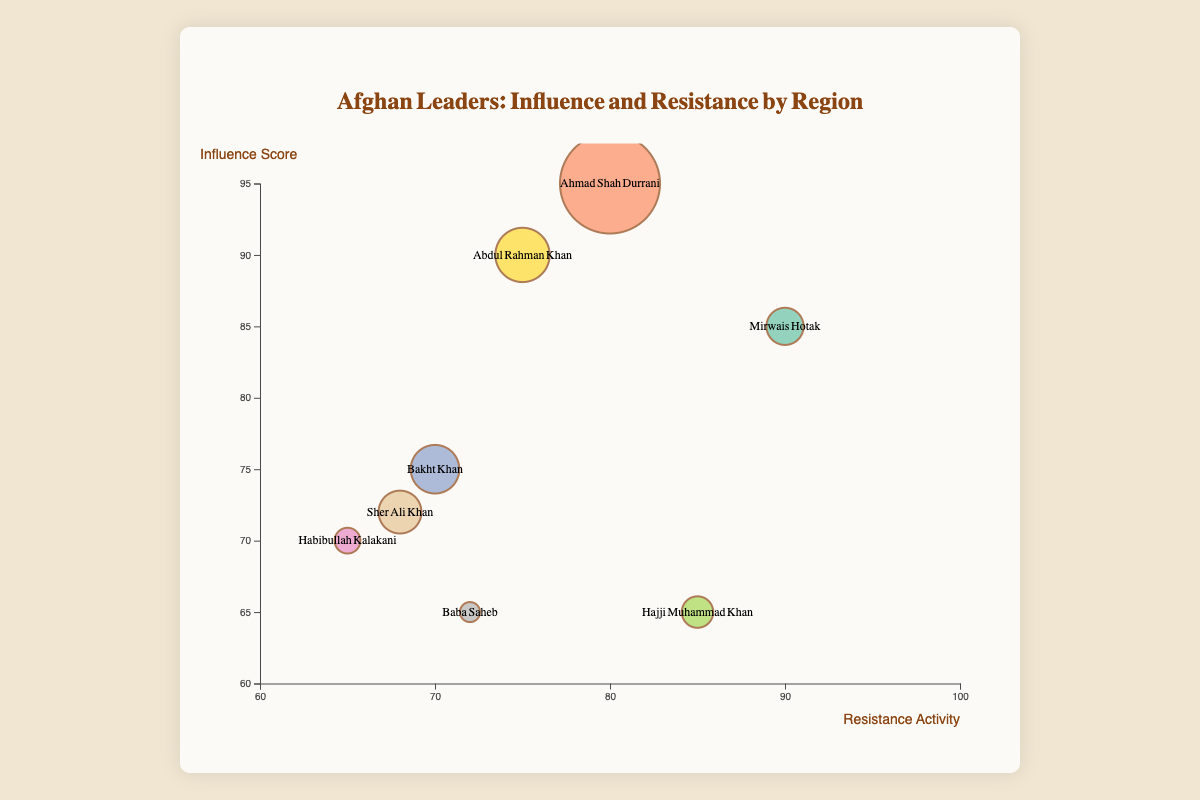What is the title of the chart? The title of the chart is found at the top of the figure, clearly indicating the focus of the visual representation.
Answer: Afghan Leaders: Influence and Resistance by Region How many data points are shown in the chart? The data points in the chart correspond to different leaders, and each is represented by a bubble. By counting the bubbles, one can determine the total number of data points.
Answer: 8 Which leader has the highest influence score? Look for the bubble positioned highest on the y-axis, as the y-axis represents the influence score.
Answer: Ahmad Shah Durrani What is the region with the largest area? The size of the bubbles indicates the region area. The largest bubble will represent the largest region.
Answer: Herat Which leader has an influence score of 70? Locate the bubble that aligns with the y-axis value of 70.
Answer: Habibullah Kalakani Between Mirwais Hotak and Hajji Muhammad Khan, who has higher resistance activity? Compare the x-axis positions of the bubbles representing these leaders; the one further to the right has higher resistance activity.
Answer: Mirwais Hotak Which region has the smallest bubble and what is its leader? The smallest bubble denotes the smallest region area. Identifying this bubble and reading the associated data provides the region and leader.
Answer: Kunduz, Baba Saheb What's the average influence score of leaders from regions with an area greater than 50? Identify the leaders from regions with areas greater than 50: Herat, Badakhshan, Ghazni, Mazar-i-Sharif. Their influence scores are 95, 75, 90, 72. Summing these gives 332, and the average is 332/4.
Answer: 83 Who has a higher resistance activity, Abdul Rahman Khan or Sher Ali Khan? Comparing the x-axis position of the bubbles for Abdul Rahman Khan and Sher Ali Khan, the one further to the right has the higher score.
Answer: Abdul Rahman Khan Which leader from the Kabul region has the lowest influence score, and what is that score? Identify the leader from Kabul, observe the y-axis position of the bubble, and read the corresponding influence score.
Answer: Habibullah Kalakani, 70 